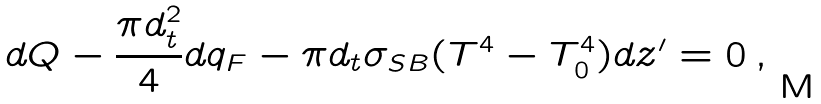Convert formula to latex. <formula><loc_0><loc_0><loc_500><loc_500>d Q - \frac { \pi d _ { t } ^ { 2 } } { 4 } d q _ { F } - \pi d _ { t } \sigma _ { S B } ( T ^ { 4 } - T _ { 0 } ^ { 4 } ) d z ^ { \prime } = 0 \, ,</formula> 